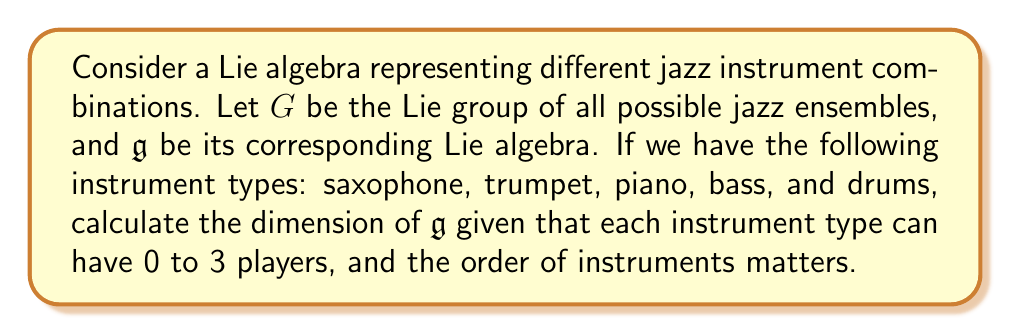Show me your answer to this math problem. To solve this problem, we need to understand how Lie algebras relate to jazz ensembles:

1) Each instrument type represents a dimension in our Lie algebra.

2) The number of players for each instrument (0 to 3) represents the possible values in each dimension.

3) The order matters, which means we're dealing with permutations rather than combinations.

Let's approach this step-by-step:

1) We have 5 instrument types: saxophone, trumpet, piano, bass, and drums.

2) For each instrument, we have 4 possibilities (0, 1, 2, or 3 players).

3) Since the order matters, we're essentially creating a 5-tuple where each element can take on 4 values.

4) This is a classic permutation with repetition problem.

5) The total number of possible ensembles is thus:

   $$4^5 = 1024$$

6) In Lie theory, the dimension of the Lie algebra $\mathfrak{g}$ is equal to the dimension of the corresponding Lie group $G$.

7) The dimension of $G$ is the number of independent parameters needed to specify an element of $G$.

8) In our case, this is precisely the number of different possible ensembles, which we calculated as 1024.

Therefore, the dimension of the Lie algebra $\mathfrak{g}$ is 1024.
Answer: The dimension of the Lie algebra $\mathfrak{g}$ is 1024. 